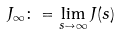<formula> <loc_0><loc_0><loc_500><loc_500>J _ { \infty } \colon = \lim _ { s \to \infty } J ( s )</formula> 